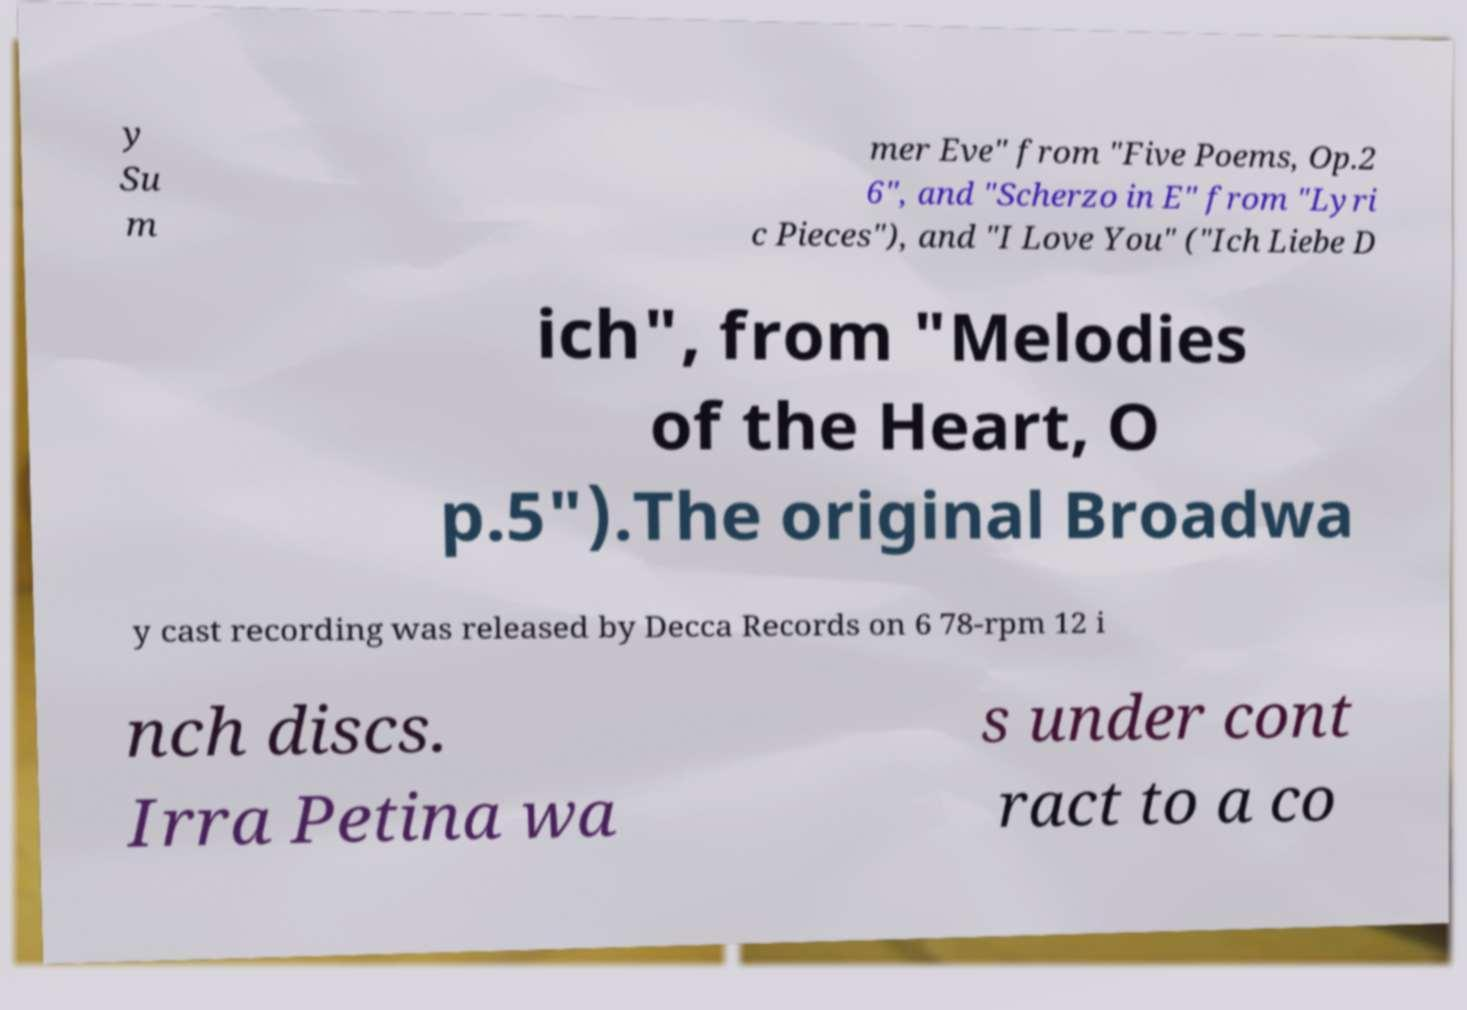Please read and relay the text visible in this image. What does it say? y Su m mer Eve" from "Five Poems, Op.2 6", and "Scherzo in E" from "Lyri c Pieces"), and "I Love You" ("Ich Liebe D ich", from "Melodies of the Heart, O p.5").The original Broadwa y cast recording was released by Decca Records on 6 78-rpm 12 i nch discs. Irra Petina wa s under cont ract to a co 